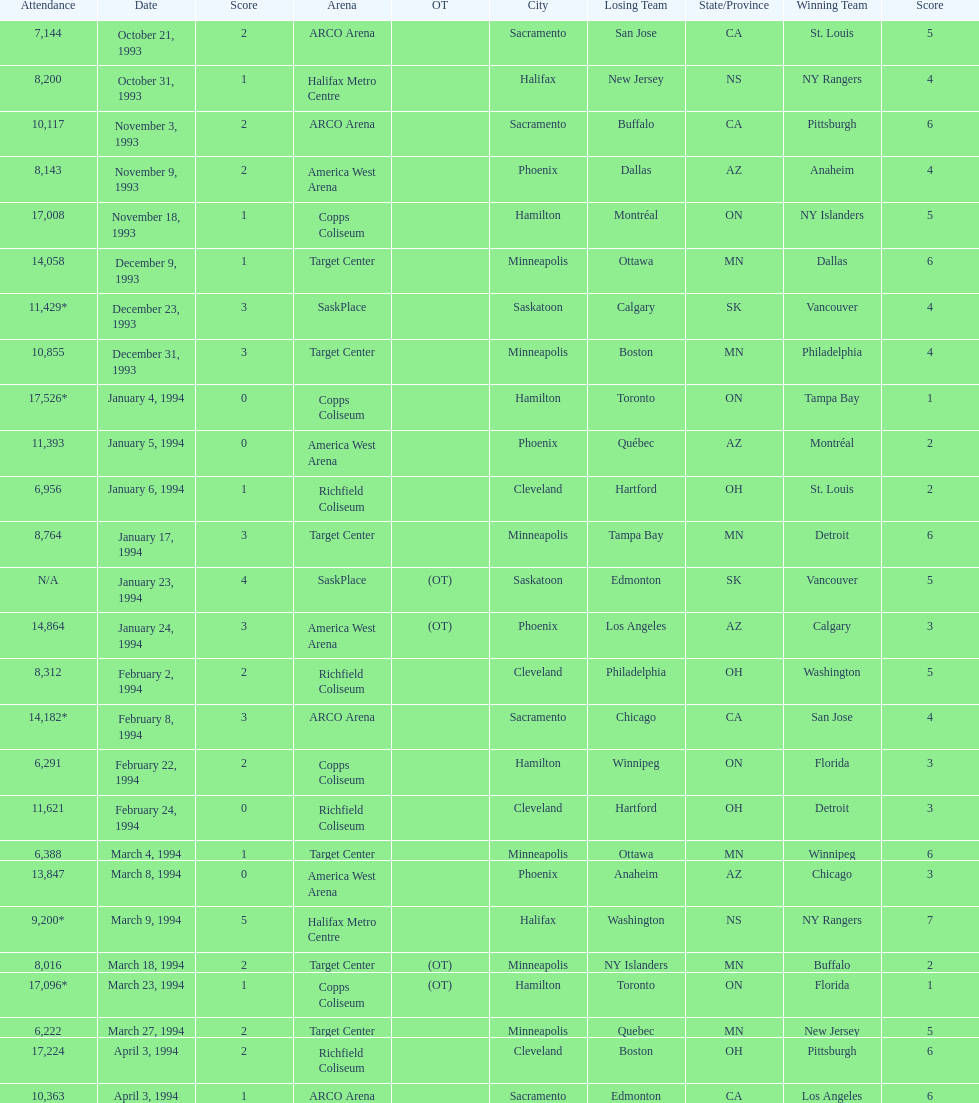What are the attendances of the 1993-94 nhl season? 7,144, 8,200, 10,117, 8,143, 17,008, 14,058, 11,429*, 10,855, 17,526*, 11,393, 6,956, 8,764, N/A, 14,864, 8,312, 14,182*, 6,291, 11,621, 6,388, 13,847, 9,200*, 8,016, 17,096*, 6,222, 17,224, 10,363. Which of these is the highest attendance? 17,526*. Which date did this attendance occur? January 4, 1994. 